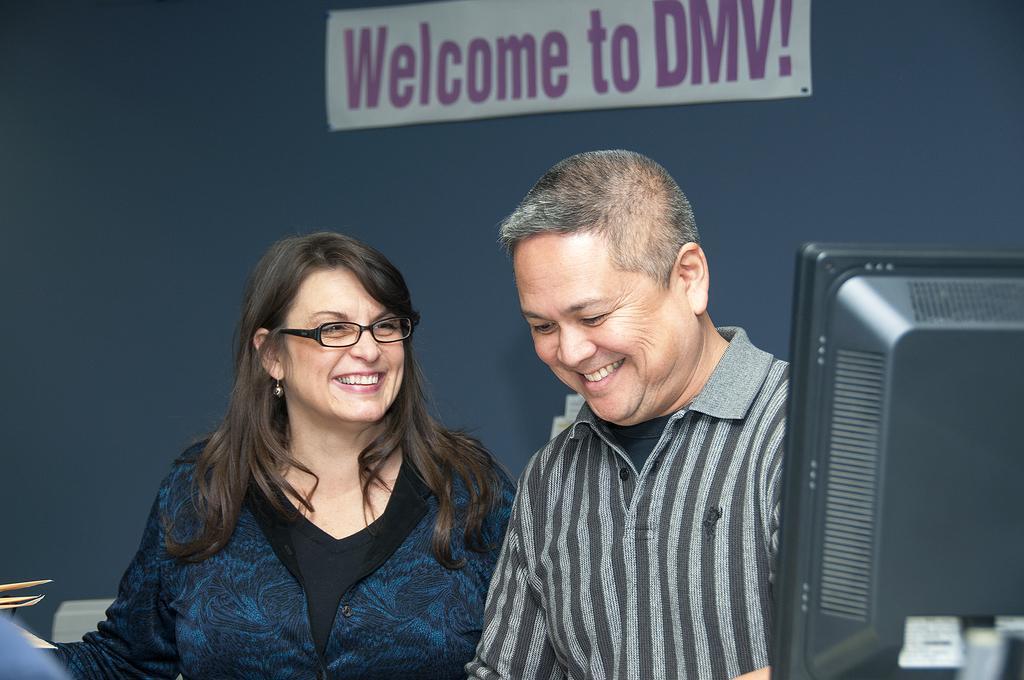Describe this image in one or two sentences. In this picture there is a man and a woman in the center of the image and there is a welcome poster at the top side of the image, there is a monitor on the right side of the image. 